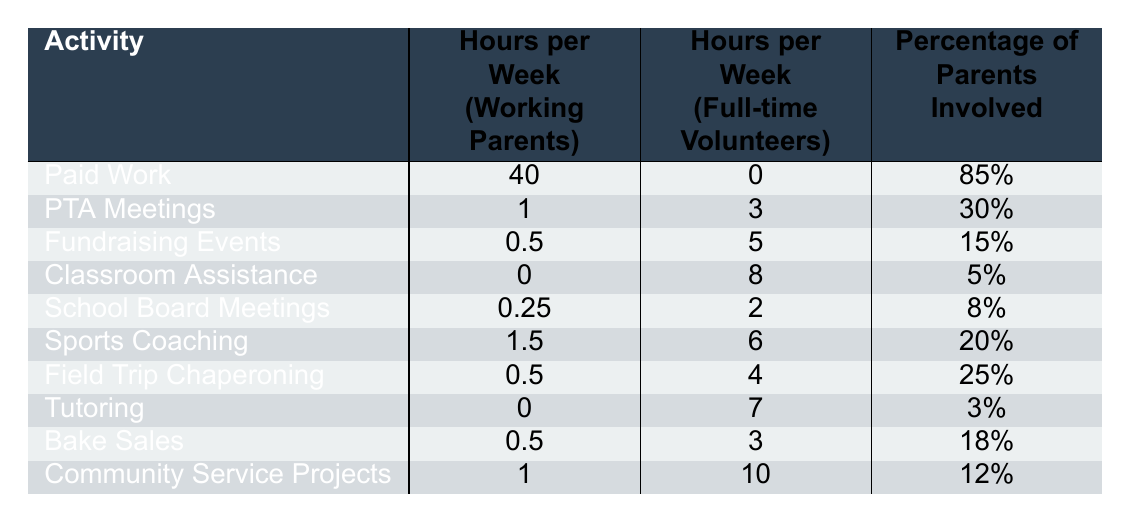What is the total time working parents spend on Paid Work and PTA Meetings? Working parents spend 40 hours on Paid Work and 1 hour on PTA Meetings. Adding these together gives 40 + 1 = 41 hours.
Answer: 41 hours How many hours do full-time volunteers spend on Community Service Projects? The table shows that full-time volunteers spend 10 hours on Community Service Projects.
Answer: 10 hours Which activity has the highest percentage of parents involved? By reviewing the "Percentage of Parents Involved" column, Paid Work has the highest value at 85%.
Answer: Paid Work What is the difference in hours spent on Fundraising Events between working parents and full-time volunteers? Working parents spend 0.5 hours on Fundraising Events while full-time volunteers spend 5 hours. The difference is 5 - 0.5 = 4.5 hours.
Answer: 4.5 hours Do more parents participate in Sports Coaching or Classroom Assistance? The percentage of parents involved in Sports Coaching is 20%, while in Classroom Assistance it is 5%. Therefore, more parents participate in Sports Coaching.
Answer: Yes What is the average number of hours that working parents spend on volunteer activities listed in the table? The volunteer activities for working parents are PTA Meetings (1), Fundraising Events (0.5), Classroom Assistance (0), School Board Meetings (0.25), Sports Coaching (1.5), Field Trip Chaperoning (0.5), Tutoring (0), Bake Sales (0.5), and Community Service Projects (1) totaling to 5.5 hours across 9 activities, resulting in an average of 5.5/9 = 0.61 hours.
Answer: 0.61 hours If a working parent decides to increase their PTA meeting time to match the full-time volunteers, how many extra hours would they need to commit per week? PTA Meetings for working parents are 1 hour while full-time volunteers spend 3 hours. The extra time needed is 3 - 1 = 2 hours.
Answer: 2 hours What is the total number of hours full-time volunteers spend on all activities combined? Summing the hours of full-time volunteers gives 3 + 5 + 8 + 2 + 6 + 4 + 7 + 3 + 10 = 48 hours.
Answer: 48 hours Is Class Room Assistance more common or less common than Fundraising Events among parents? Classroom Assistance has 5% involvement while Fundraising Events has 15%. Since 5% is less than 15%, Classroom Assistance is less common.
Answer: Less common What percentage of parents are involved in Bake Sales? The table indicates that 18% of parents are involved in Bake Sales.
Answer: 18% How does the time spent on tutoring compare between working parents and full-time volunteers? Working parents spend 0 hours on tutoring, while full-time volunteers spend 7 hours. This indicates a significant difference as volunteers commit time while working parents do not.
Answer: Full-time volunteers spend more time 